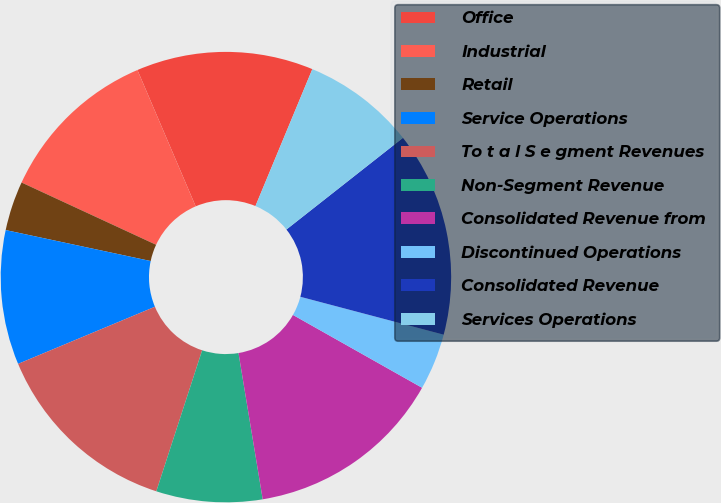Convert chart. <chart><loc_0><loc_0><loc_500><loc_500><pie_chart><fcel>Office<fcel>Industrial<fcel>Retail<fcel>Service Operations<fcel>To t a l S e gment Revenues<fcel>Non-Segment Revenue<fcel>Consolidated Revenue from<fcel>Discontinued Operations<fcel>Consolidated Revenue<fcel>Services Operations<nl><fcel>12.69%<fcel>11.67%<fcel>3.55%<fcel>9.64%<fcel>13.7%<fcel>7.61%<fcel>14.21%<fcel>4.06%<fcel>14.72%<fcel>8.12%<nl></chart> 